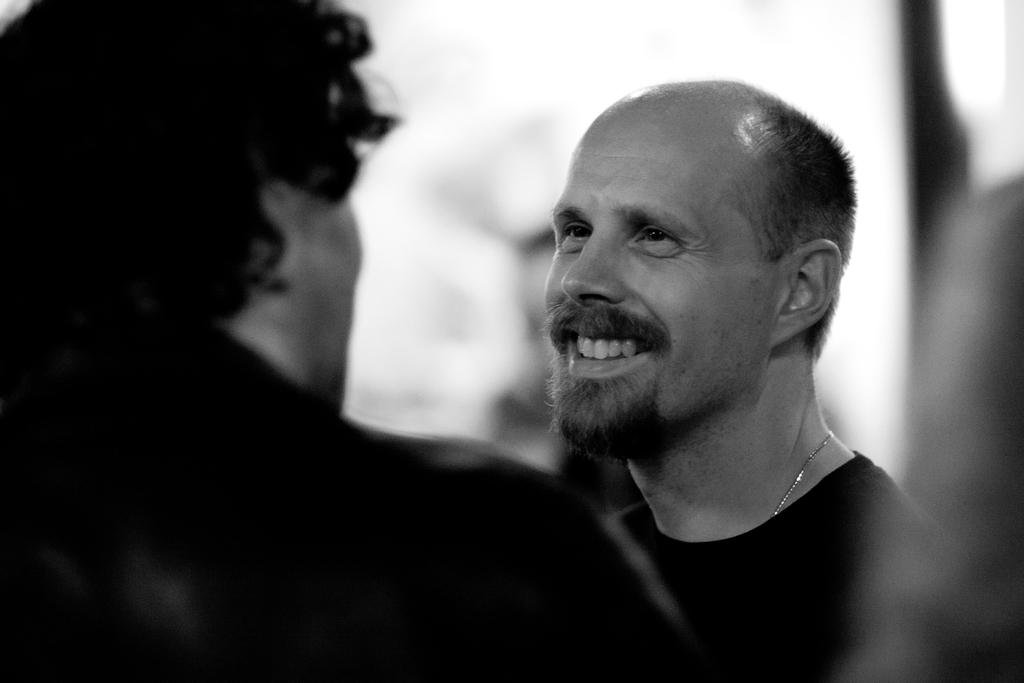What is the color scheme of the image? The image is black and white. Who is present in the image? There is a man in the image. What is the man doing in the image? The man is smiling and watching another person. How is the background and right side of the image depicted? The background and right side of the image have a blurred view. What type of silver object is visible in the image? There is no silver object present in the image. Can you describe the feet of the person being watched in the image? There is no information about the feet of the person being watched in the image, as the focus is on the man's facial expression and the blurred background. 